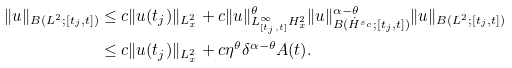Convert formula to latex. <formula><loc_0><loc_0><loc_500><loc_500>\| u \| _ { B ( L ^ { 2 } ; [ t _ { j } , t ] ) } & \leq c \| u ( t _ { j } ) \| _ { L ^ { 2 } _ { x } } + c \| u \| ^ { \theta } _ { L ^ { \infty } _ { [ t _ { j } , t ] } H ^ { 2 } _ { x } } \| u \| ^ { \alpha - \theta } _ { B ( \dot { H } ^ { s _ { c } } ; [ t _ { j } , t ] ) } \| u \| _ { B ( L ^ { 2 } ; [ t _ { j } , t ] ) } \\ & \leq c \| u ( t _ { j } ) \| _ { L ^ { 2 } _ { x } } + c \eta ^ { \theta } \delta ^ { \alpha - \theta } A ( t ) .</formula> 